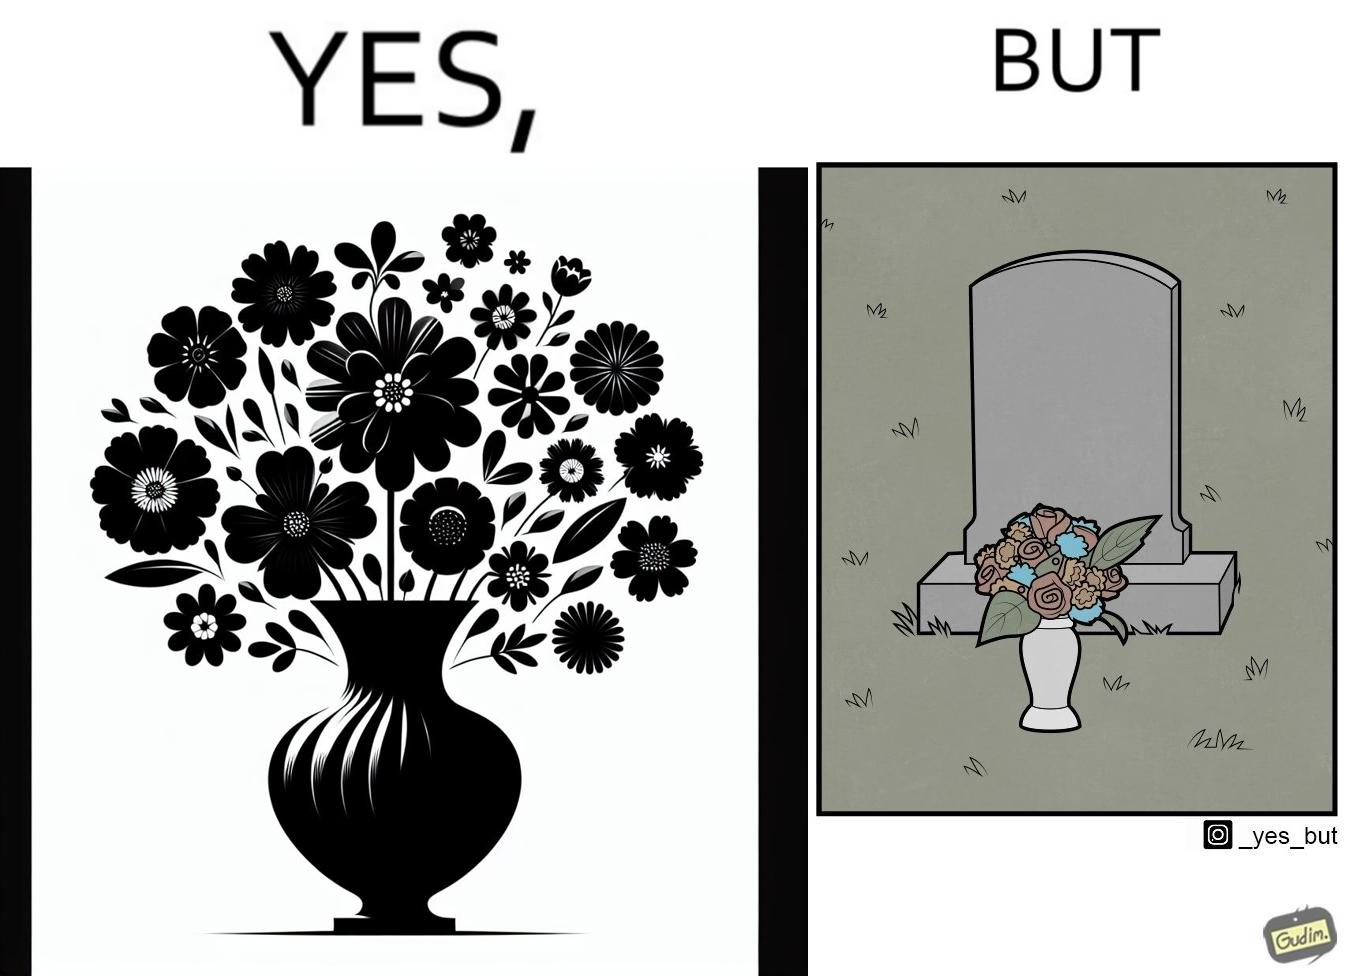Is this image satirical or non-satirical? Yes, this image is satirical. 